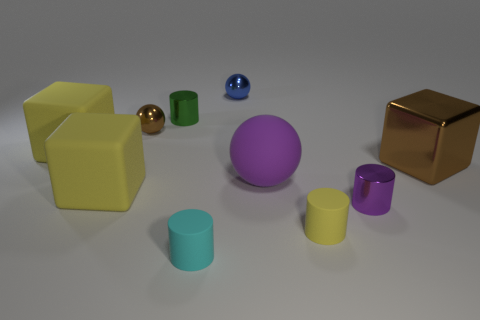Subtract all purple metal cylinders. How many cylinders are left? 3 Subtract all yellow cylinders. How many cylinders are left? 3 Subtract all brown cylinders. Subtract all yellow blocks. How many cylinders are left? 4 Subtract all balls. How many objects are left? 7 Add 2 tiny gray cubes. How many tiny gray cubes exist? 2 Subtract 0 red balls. How many objects are left? 10 Subtract all green metallic objects. Subtract all tiny cyan rubber objects. How many objects are left? 8 Add 2 cyan rubber things. How many cyan rubber things are left? 3 